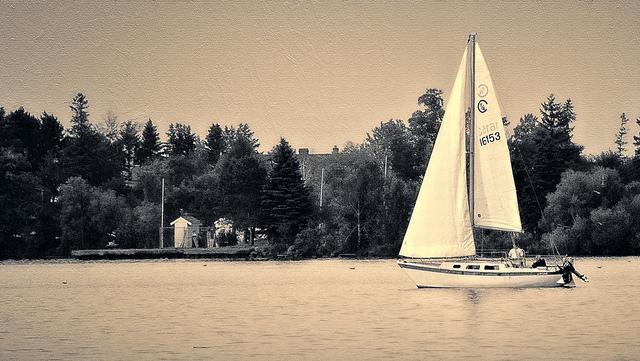How many carrots are on the plate?
Give a very brief answer. 0. 